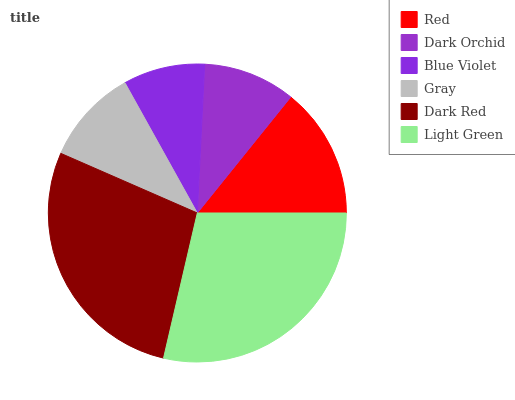Is Blue Violet the minimum?
Answer yes or no. Yes. Is Light Green the maximum?
Answer yes or no. Yes. Is Dark Orchid the minimum?
Answer yes or no. No. Is Dark Orchid the maximum?
Answer yes or no. No. Is Red greater than Dark Orchid?
Answer yes or no. Yes. Is Dark Orchid less than Red?
Answer yes or no. Yes. Is Dark Orchid greater than Red?
Answer yes or no. No. Is Red less than Dark Orchid?
Answer yes or no. No. Is Red the high median?
Answer yes or no. Yes. Is Gray the low median?
Answer yes or no. Yes. Is Blue Violet the high median?
Answer yes or no. No. Is Dark Red the low median?
Answer yes or no. No. 